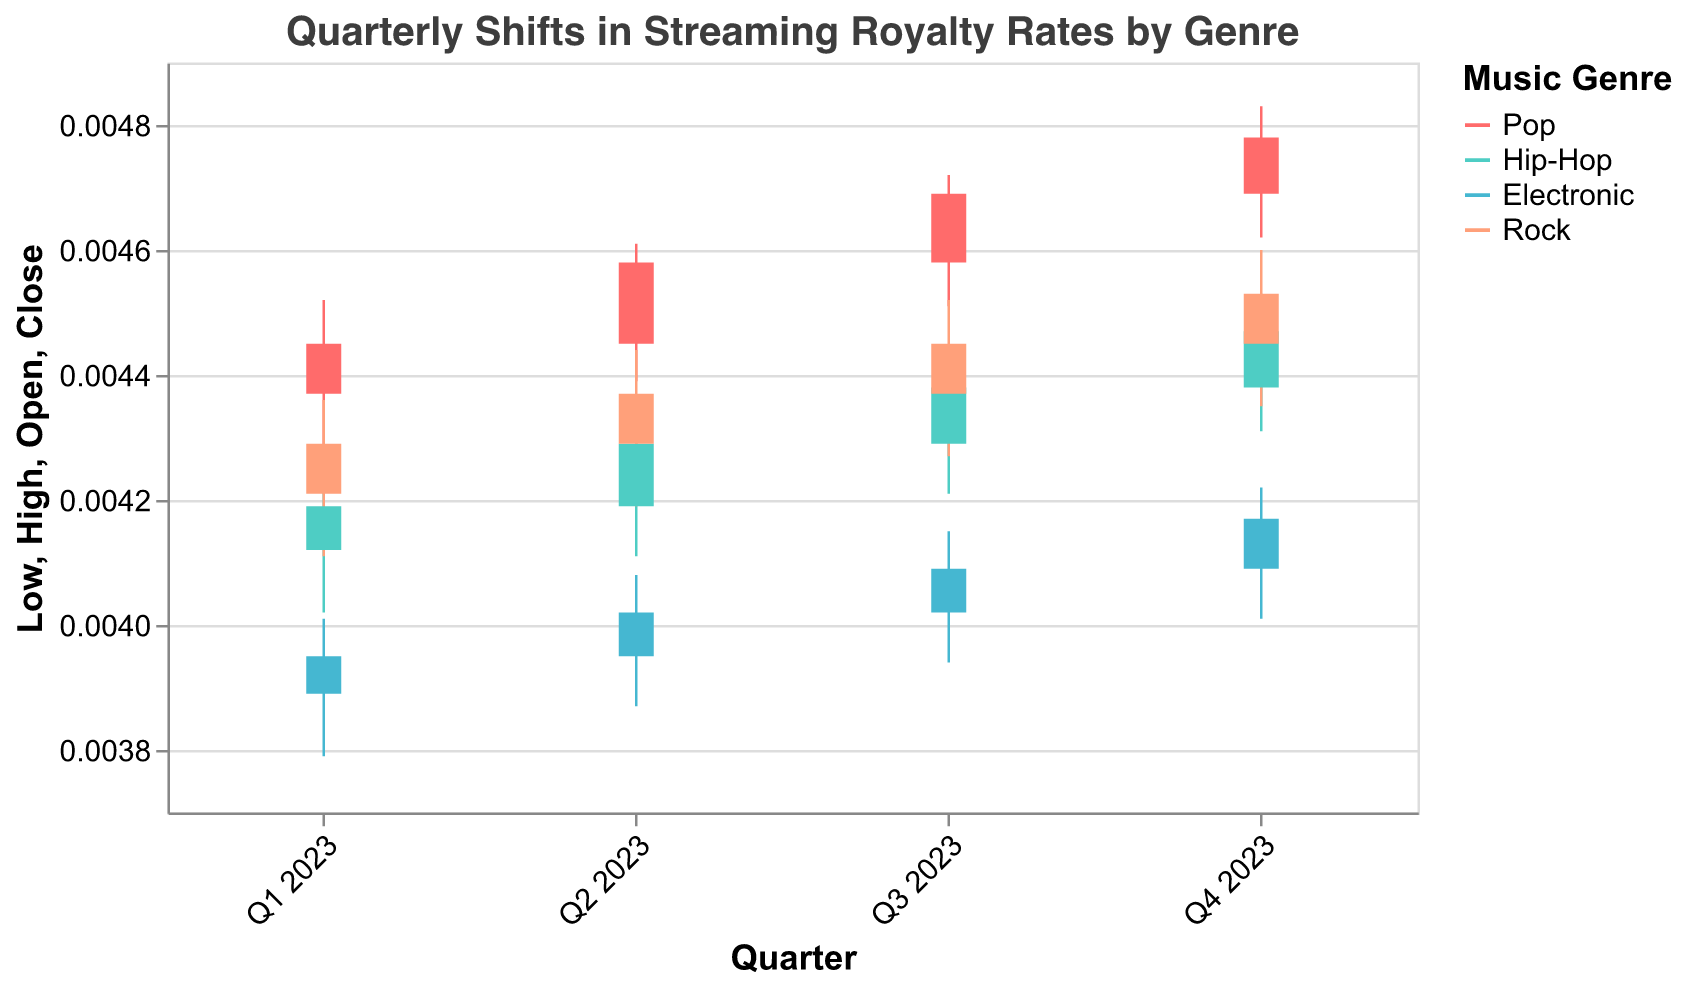What is the title of the figure? The title is usually provided at the top of the figure. For this chart, it is visible as the main heading which reads "Quarterly Shifts in Streaming Royalty Rates by Genre".
Answer: Quarterly Shifts in Streaming Royalty Rates by Genre Which genre had the highest royalty rate in Q4 2023? To determine this, identify the data points for Q4 2023 for each genre and compare their "High" values. The genre with the highest of these values is the one with the highest royalty rate. From the data, Pop had the highest rate of 0.00483.
Answer: Pop What is the color used to represent the Hip-Hop genre? The colors for each genre are distinguished in the legend. According to the legend, Hip-Hop is represented by the color teal.
Answer: Teal How did the Pop genre's royalty rate change from Q1 2023 to Q2 2023? To track this change, compare the "Close" value of Q1 2023 with the "Close" value of Q2 2023 for the Pop genre. The values are 0.00445 (Q1) and 0.00458 (Q2), indicating an increase.
Answer: Increased In which quarter did the Electronic genre have the lowest "Low" value? Examine the "Low" values for the Electronic genre across the quarters. The lowest value is 0.00379 in Q1 2023.
Answer: Q1 2023 Which quarter shows the smallest difference between the "High" and "Low" values for Rock? For each quarter, calculate the difference between "High" and "Low" values for Rock. The quarter with the smallest difference is Q4 2023 where the values are 0.00460 and 0.00435, resulting in a difference of 0.00025.
Answer: Q4 2023 What is the average "Close" value for Hip-Hop across all quarters? Sum the "Close" values for Hip-Hop across all quarters and divide by the number of quarters. The values are 0.00419, 0.00429, 0.00438, and 0.00447, resulting in (0.00419 + 0.00429 + 0.00438 + 0.00447) / 4 = 0.0043325.
Answer: 0.0043325 Compare the "Open" value of Rock in Q1 2023 with the "Close" value in the same quarter. Which one is higher? The "Open" and "Close" values for Rock in Q1 2023 are 0.00421 and 0.00429, respectively. The "Close" value is higher than the "Open" value.
Answer: Close How much did the Pop genre's "High" value increase from Q1 2023 to Q4 2023? Subtract the "High" value of Q1 2023 from Q4 2023 for the Pop genre. The values are 0.00483 (Q4) and 0.00452 (Q1), resulting in an increase of 0.00483 - 0.00452 = 0.00031.
Answer: 0.00031 